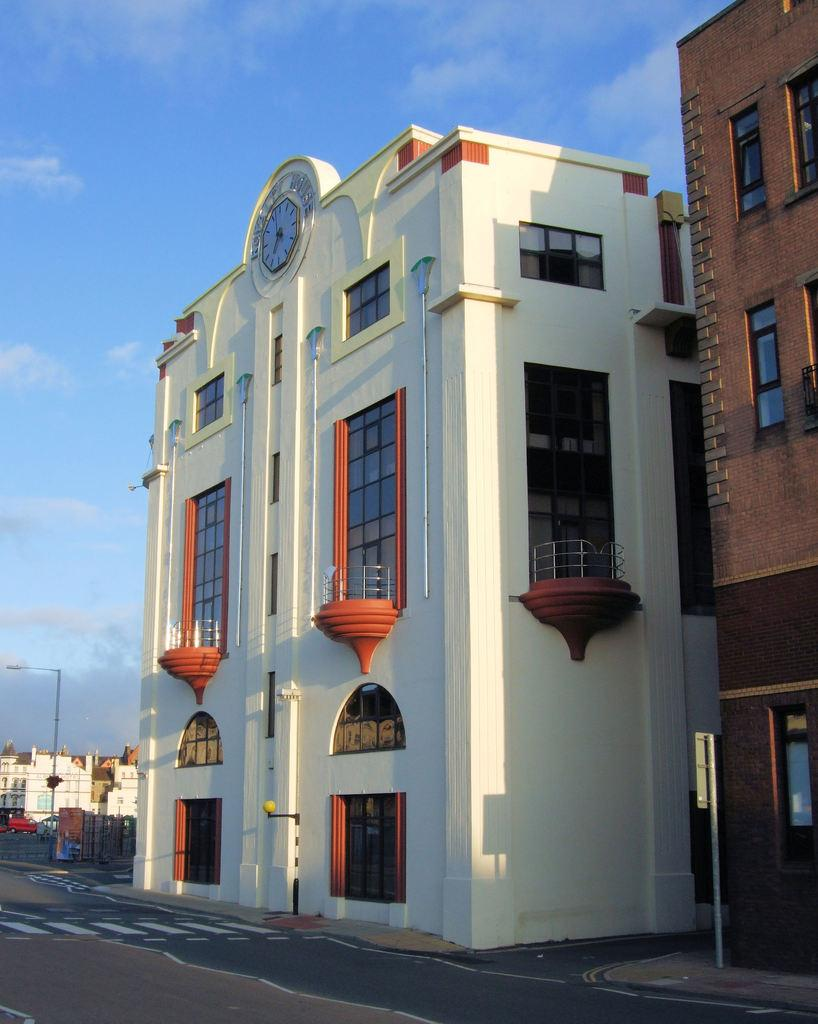What type of structures are present in the image? There are buildings in the image. What can be seen in the image besides the buildings? There is a pole, a road, and a clock visible in the image. What is the condition of the sky in the image? The sky is cloudy in the image. What type of pathway is present in the image? There is a road in the image, but there is no mention of a sidewalk. How many eggs are visible on the pole in the image? There are no eggs present on the pole or anywhere else in the image. What type of wish can be granted by the clock in the image? There is no mention of a wish or any magical properties associated with the clock in the image. 